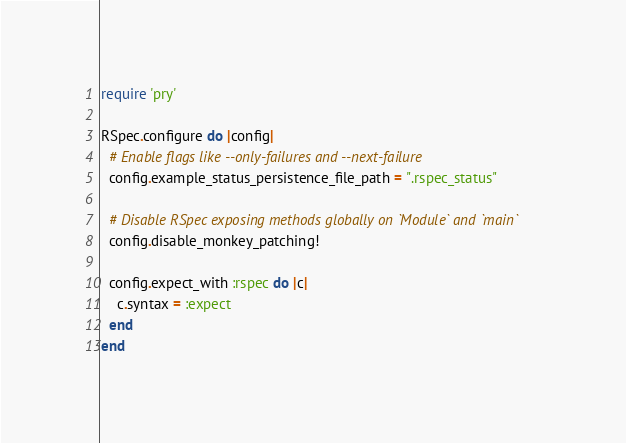Convert code to text. <code><loc_0><loc_0><loc_500><loc_500><_Ruby_>require 'pry'

RSpec.configure do |config|
  # Enable flags like --only-failures and --next-failure
  config.example_status_persistence_file_path = ".rspec_status"

  # Disable RSpec exposing methods globally on `Module` and `main`
  config.disable_monkey_patching!

  config.expect_with :rspec do |c|
    c.syntax = :expect
  end
end
</code> 